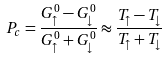Convert formula to latex. <formula><loc_0><loc_0><loc_500><loc_500>P _ { c } = \frac { G _ { \uparrow } ^ { 0 } - G _ { \downarrow } ^ { 0 } } { G _ { \uparrow } ^ { 0 } + G _ { \downarrow } ^ { 0 } } \approx \frac { T _ { \uparrow } - T _ { \downarrow } } { T _ { \uparrow } + T _ { \downarrow } }</formula> 